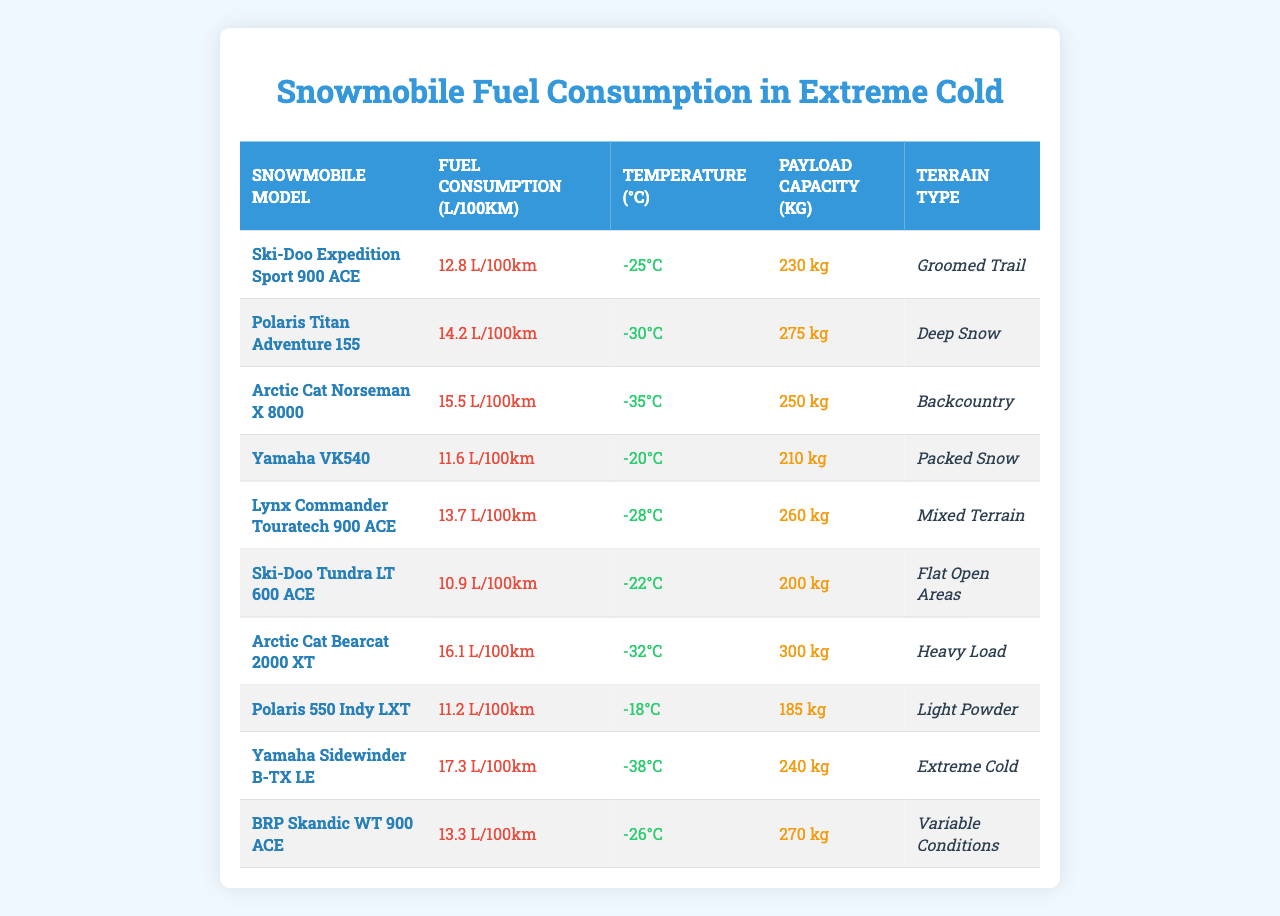What is the fuel consumption of the Ski-Doo Tundra LT 600 ACE? The table specifies that the fuel consumption for the Ski-Doo Tundra LT 600 ACE is listed directly as 10.9 L/100km.
Answer: 10.9 L/100km Which snowmobile model has the highest fuel consumption rate? Looking through the fuel consumption values in the table, the Yamaha Sidewinder B-TX LE has the highest consumption at 17.3 L/100km.
Answer: Yamaha Sidewinder B-TX LE What is the average fuel consumption of all snowmobiles listed? To find the average fuel consumption, I add all the values: (12.8 + 14.2 + 15.5 + 11.6 + 13.7 + 10.9 + 16.1 + 11.2 + 17.3 + 13.3) = 14.06. Dividing by 10 gives an average of 14.06 L/100km.
Answer: 14.06 L/100km Is the fuel consumption of the Polaris 550 Indy LXT lower than 12 L/100km? The Polaris 550 Indy LXT has a fuel consumption of 11.2 L/100km, which is indeed lower than 12 L/100km.
Answer: Yes How many snowmobile models have a fuel consumption rate above 15 L/100km? There are four models: the Polaris Titan Adventure 155 (14.2), Arctic Cat Norseman X 8000 (15.5), Arctic Cat Bearcat 2000 XT (16.1), and Yamaha Sidewinder B-TX LE (17.3) which all exceed this threshold.
Answer: Four Which snowmobile can carry the most payload? The Arctic Cat Bearcat 2000 XT has the highest payload capacity listed at 300 kg, making it the model that can carry the most.
Answer: Arctic Cat Bearcat 2000 XT Are any of the snowmobiles equipped for extreme cold temperatures? Yes, the Yamaha Sidewinder B-TX LE is specifically designed for extreme cold, having a temperature rating of -38°C.
Answer: Yes What is the sum of the payload capacities of Polaris Titan Adventure 155 and Lynx Commander Touratech 900 ACE? The Polaris Titan Adventure 155 has a payload of 275 kg and the Lynx Commander Touratech 900 ACE has 260 kg. Adding both gives 275 kg + 260 kg = 535 kg.
Answer: 535 kg Which snowmobile is the most fuel-efficient in extreme cold conditions? The Ski-Doo Tundra LT 600 ACE has the lowest fuel consumption at 10.9 L/100km among the models listed for extreme cold conditions.
Answer: Ski-Doo Tundra LT 600 ACE What terrains can the Arctic Cat Norseman X 8000 operate on? According to the table, the Arctic Cat Norseman X 8000 is suitable for Backcountry terrain.
Answer: Backcountry 